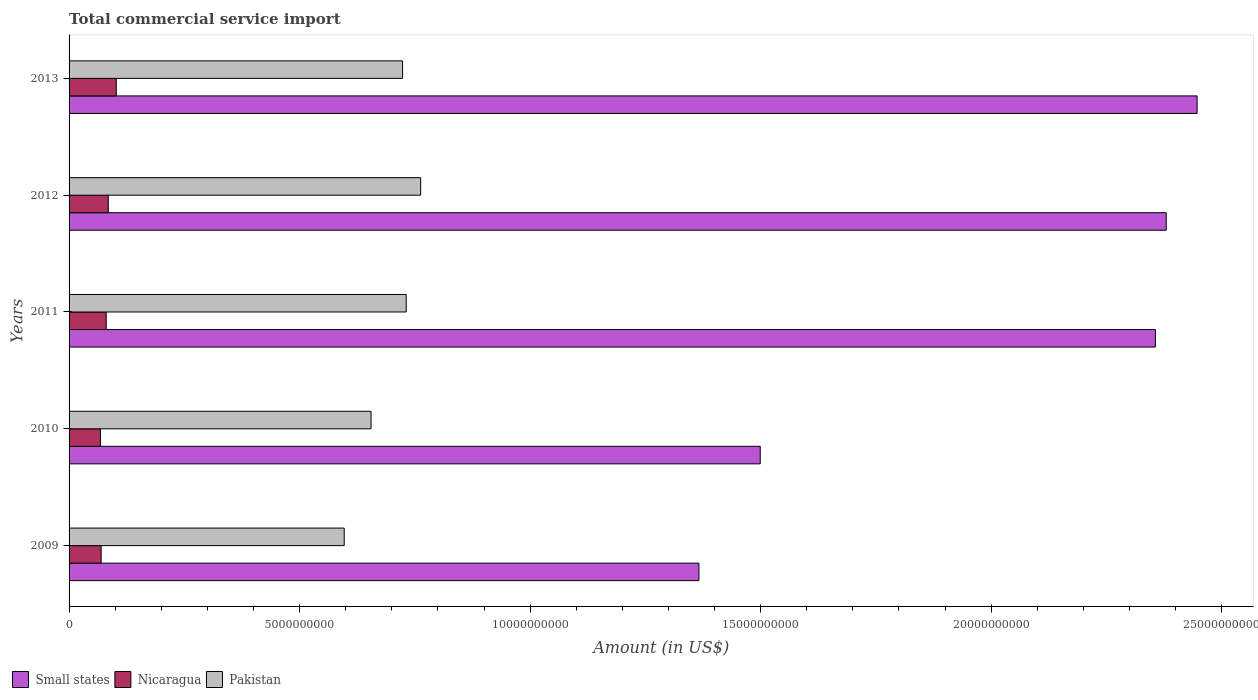How many different coloured bars are there?
Keep it short and to the point. 3. Are the number of bars on each tick of the Y-axis equal?
Keep it short and to the point. Yes. How many bars are there on the 1st tick from the top?
Give a very brief answer. 3. What is the label of the 5th group of bars from the top?
Provide a succinct answer. 2009. What is the total commercial service import in Pakistan in 2011?
Provide a short and direct response. 7.31e+09. Across all years, what is the maximum total commercial service import in Pakistan?
Ensure brevity in your answer.  7.63e+09. Across all years, what is the minimum total commercial service import in Nicaragua?
Keep it short and to the point. 6.80e+08. In which year was the total commercial service import in Small states minimum?
Ensure brevity in your answer.  2009. What is the total total commercial service import in Pakistan in the graph?
Ensure brevity in your answer.  3.47e+1. What is the difference between the total commercial service import in Nicaragua in 2012 and that in 2013?
Keep it short and to the point. -1.73e+08. What is the difference between the total commercial service import in Pakistan in 2010 and the total commercial service import in Nicaragua in 2011?
Provide a succinct answer. 5.74e+09. What is the average total commercial service import in Nicaragua per year?
Offer a very short reply. 8.11e+08. In the year 2010, what is the difference between the total commercial service import in Small states and total commercial service import in Nicaragua?
Ensure brevity in your answer.  1.43e+1. In how many years, is the total commercial service import in Pakistan greater than 24000000000 US$?
Provide a short and direct response. 0. What is the ratio of the total commercial service import in Nicaragua in 2011 to that in 2012?
Your response must be concise. 0.95. Is the difference between the total commercial service import in Small states in 2012 and 2013 greater than the difference between the total commercial service import in Nicaragua in 2012 and 2013?
Keep it short and to the point. No. What is the difference between the highest and the second highest total commercial service import in Pakistan?
Ensure brevity in your answer.  3.13e+08. What is the difference between the highest and the lowest total commercial service import in Small states?
Offer a very short reply. 1.08e+1. In how many years, is the total commercial service import in Small states greater than the average total commercial service import in Small states taken over all years?
Make the answer very short. 3. What does the 2nd bar from the top in 2010 represents?
Offer a very short reply. Nicaragua. What does the 2nd bar from the bottom in 2010 represents?
Give a very brief answer. Nicaragua. How many bars are there?
Provide a short and direct response. 15. Are all the bars in the graph horizontal?
Provide a short and direct response. Yes. Are the values on the major ticks of X-axis written in scientific E-notation?
Provide a succinct answer. No. Does the graph contain grids?
Your answer should be very brief. No. Where does the legend appear in the graph?
Offer a very short reply. Bottom left. How many legend labels are there?
Ensure brevity in your answer.  3. What is the title of the graph?
Make the answer very short. Total commercial service import. Does "Suriname" appear as one of the legend labels in the graph?
Provide a short and direct response. No. What is the label or title of the X-axis?
Your answer should be very brief. Amount (in US$). What is the label or title of the Y-axis?
Offer a terse response. Years. What is the Amount (in US$) in Small states in 2009?
Your response must be concise. 1.37e+1. What is the Amount (in US$) in Nicaragua in 2009?
Ensure brevity in your answer.  6.96e+08. What is the Amount (in US$) of Pakistan in 2009?
Offer a terse response. 5.97e+09. What is the Amount (in US$) of Small states in 2010?
Provide a short and direct response. 1.50e+1. What is the Amount (in US$) of Nicaragua in 2010?
Provide a succinct answer. 6.80e+08. What is the Amount (in US$) of Pakistan in 2010?
Your answer should be compact. 6.55e+09. What is the Amount (in US$) of Small states in 2011?
Ensure brevity in your answer.  2.36e+1. What is the Amount (in US$) in Nicaragua in 2011?
Your response must be concise. 8.05e+08. What is the Amount (in US$) of Pakistan in 2011?
Your answer should be very brief. 7.31e+09. What is the Amount (in US$) of Small states in 2012?
Offer a very short reply. 2.38e+1. What is the Amount (in US$) of Nicaragua in 2012?
Keep it short and to the point. 8.51e+08. What is the Amount (in US$) in Pakistan in 2012?
Make the answer very short. 7.63e+09. What is the Amount (in US$) of Small states in 2013?
Provide a succinct answer. 2.45e+1. What is the Amount (in US$) in Nicaragua in 2013?
Your answer should be compact. 1.02e+09. What is the Amount (in US$) of Pakistan in 2013?
Your answer should be very brief. 7.23e+09. Across all years, what is the maximum Amount (in US$) in Small states?
Keep it short and to the point. 2.45e+1. Across all years, what is the maximum Amount (in US$) of Nicaragua?
Provide a short and direct response. 1.02e+09. Across all years, what is the maximum Amount (in US$) in Pakistan?
Offer a terse response. 7.63e+09. Across all years, what is the minimum Amount (in US$) in Small states?
Provide a succinct answer. 1.37e+1. Across all years, what is the minimum Amount (in US$) of Nicaragua?
Make the answer very short. 6.80e+08. Across all years, what is the minimum Amount (in US$) in Pakistan?
Your answer should be compact. 5.97e+09. What is the total Amount (in US$) in Small states in the graph?
Keep it short and to the point. 1.00e+11. What is the total Amount (in US$) of Nicaragua in the graph?
Your response must be concise. 4.06e+09. What is the total Amount (in US$) in Pakistan in the graph?
Your answer should be very brief. 3.47e+1. What is the difference between the Amount (in US$) in Small states in 2009 and that in 2010?
Your answer should be very brief. -1.33e+09. What is the difference between the Amount (in US$) of Nicaragua in 2009 and that in 2010?
Ensure brevity in your answer.  1.56e+07. What is the difference between the Amount (in US$) of Pakistan in 2009 and that in 2010?
Give a very brief answer. -5.83e+08. What is the difference between the Amount (in US$) in Small states in 2009 and that in 2011?
Provide a short and direct response. -9.90e+09. What is the difference between the Amount (in US$) of Nicaragua in 2009 and that in 2011?
Offer a terse response. -1.10e+08. What is the difference between the Amount (in US$) of Pakistan in 2009 and that in 2011?
Provide a succinct answer. -1.35e+09. What is the difference between the Amount (in US$) of Small states in 2009 and that in 2012?
Offer a very short reply. -1.01e+1. What is the difference between the Amount (in US$) in Nicaragua in 2009 and that in 2012?
Keep it short and to the point. -1.55e+08. What is the difference between the Amount (in US$) of Pakistan in 2009 and that in 2012?
Make the answer very short. -1.66e+09. What is the difference between the Amount (in US$) in Small states in 2009 and that in 2013?
Offer a terse response. -1.08e+1. What is the difference between the Amount (in US$) in Nicaragua in 2009 and that in 2013?
Provide a succinct answer. -3.28e+08. What is the difference between the Amount (in US$) of Pakistan in 2009 and that in 2013?
Provide a short and direct response. -1.27e+09. What is the difference between the Amount (in US$) of Small states in 2010 and that in 2011?
Ensure brevity in your answer.  -8.57e+09. What is the difference between the Amount (in US$) of Nicaragua in 2010 and that in 2011?
Ensure brevity in your answer.  -1.25e+08. What is the difference between the Amount (in US$) of Pakistan in 2010 and that in 2011?
Provide a succinct answer. -7.63e+08. What is the difference between the Amount (in US$) in Small states in 2010 and that in 2012?
Offer a very short reply. -8.81e+09. What is the difference between the Amount (in US$) in Nicaragua in 2010 and that in 2012?
Your answer should be compact. -1.71e+08. What is the difference between the Amount (in US$) of Pakistan in 2010 and that in 2012?
Your answer should be compact. -1.08e+09. What is the difference between the Amount (in US$) of Small states in 2010 and that in 2013?
Your answer should be compact. -9.48e+09. What is the difference between the Amount (in US$) of Nicaragua in 2010 and that in 2013?
Ensure brevity in your answer.  -3.44e+08. What is the difference between the Amount (in US$) in Pakistan in 2010 and that in 2013?
Your response must be concise. -6.84e+08. What is the difference between the Amount (in US$) of Small states in 2011 and that in 2012?
Provide a short and direct response. -2.34e+08. What is the difference between the Amount (in US$) in Nicaragua in 2011 and that in 2012?
Offer a terse response. -4.55e+07. What is the difference between the Amount (in US$) of Pakistan in 2011 and that in 2012?
Ensure brevity in your answer.  -3.13e+08. What is the difference between the Amount (in US$) in Small states in 2011 and that in 2013?
Give a very brief answer. -9.04e+08. What is the difference between the Amount (in US$) in Nicaragua in 2011 and that in 2013?
Your answer should be very brief. -2.19e+08. What is the difference between the Amount (in US$) of Pakistan in 2011 and that in 2013?
Provide a short and direct response. 7.90e+07. What is the difference between the Amount (in US$) of Small states in 2012 and that in 2013?
Provide a short and direct response. -6.70e+08. What is the difference between the Amount (in US$) in Nicaragua in 2012 and that in 2013?
Your response must be concise. -1.73e+08. What is the difference between the Amount (in US$) in Pakistan in 2012 and that in 2013?
Offer a terse response. 3.92e+08. What is the difference between the Amount (in US$) of Small states in 2009 and the Amount (in US$) of Nicaragua in 2010?
Make the answer very short. 1.30e+1. What is the difference between the Amount (in US$) in Small states in 2009 and the Amount (in US$) in Pakistan in 2010?
Make the answer very short. 7.11e+09. What is the difference between the Amount (in US$) in Nicaragua in 2009 and the Amount (in US$) in Pakistan in 2010?
Your response must be concise. -5.85e+09. What is the difference between the Amount (in US$) of Small states in 2009 and the Amount (in US$) of Nicaragua in 2011?
Provide a short and direct response. 1.29e+1. What is the difference between the Amount (in US$) of Small states in 2009 and the Amount (in US$) of Pakistan in 2011?
Give a very brief answer. 6.35e+09. What is the difference between the Amount (in US$) of Nicaragua in 2009 and the Amount (in US$) of Pakistan in 2011?
Your answer should be very brief. -6.62e+09. What is the difference between the Amount (in US$) of Small states in 2009 and the Amount (in US$) of Nicaragua in 2012?
Give a very brief answer. 1.28e+1. What is the difference between the Amount (in US$) of Small states in 2009 and the Amount (in US$) of Pakistan in 2012?
Your response must be concise. 6.04e+09. What is the difference between the Amount (in US$) of Nicaragua in 2009 and the Amount (in US$) of Pakistan in 2012?
Ensure brevity in your answer.  -6.93e+09. What is the difference between the Amount (in US$) in Small states in 2009 and the Amount (in US$) in Nicaragua in 2013?
Provide a short and direct response. 1.26e+1. What is the difference between the Amount (in US$) of Small states in 2009 and the Amount (in US$) of Pakistan in 2013?
Make the answer very short. 6.43e+09. What is the difference between the Amount (in US$) in Nicaragua in 2009 and the Amount (in US$) in Pakistan in 2013?
Give a very brief answer. -6.54e+09. What is the difference between the Amount (in US$) in Small states in 2010 and the Amount (in US$) in Nicaragua in 2011?
Your answer should be very brief. 1.42e+1. What is the difference between the Amount (in US$) of Small states in 2010 and the Amount (in US$) of Pakistan in 2011?
Offer a terse response. 7.68e+09. What is the difference between the Amount (in US$) of Nicaragua in 2010 and the Amount (in US$) of Pakistan in 2011?
Offer a very short reply. -6.63e+09. What is the difference between the Amount (in US$) in Small states in 2010 and the Amount (in US$) in Nicaragua in 2012?
Provide a short and direct response. 1.41e+1. What is the difference between the Amount (in US$) in Small states in 2010 and the Amount (in US$) in Pakistan in 2012?
Provide a short and direct response. 7.36e+09. What is the difference between the Amount (in US$) in Nicaragua in 2010 and the Amount (in US$) in Pakistan in 2012?
Your answer should be very brief. -6.95e+09. What is the difference between the Amount (in US$) in Small states in 2010 and the Amount (in US$) in Nicaragua in 2013?
Your response must be concise. 1.40e+1. What is the difference between the Amount (in US$) of Small states in 2010 and the Amount (in US$) of Pakistan in 2013?
Keep it short and to the point. 7.76e+09. What is the difference between the Amount (in US$) of Nicaragua in 2010 and the Amount (in US$) of Pakistan in 2013?
Ensure brevity in your answer.  -6.55e+09. What is the difference between the Amount (in US$) in Small states in 2011 and the Amount (in US$) in Nicaragua in 2012?
Offer a terse response. 2.27e+1. What is the difference between the Amount (in US$) of Small states in 2011 and the Amount (in US$) of Pakistan in 2012?
Your answer should be very brief. 1.59e+1. What is the difference between the Amount (in US$) in Nicaragua in 2011 and the Amount (in US$) in Pakistan in 2012?
Provide a succinct answer. -6.82e+09. What is the difference between the Amount (in US$) in Small states in 2011 and the Amount (in US$) in Nicaragua in 2013?
Provide a short and direct response. 2.25e+1. What is the difference between the Amount (in US$) in Small states in 2011 and the Amount (in US$) in Pakistan in 2013?
Offer a very short reply. 1.63e+1. What is the difference between the Amount (in US$) of Nicaragua in 2011 and the Amount (in US$) of Pakistan in 2013?
Offer a terse response. -6.43e+09. What is the difference between the Amount (in US$) of Small states in 2012 and the Amount (in US$) of Nicaragua in 2013?
Keep it short and to the point. 2.28e+1. What is the difference between the Amount (in US$) of Small states in 2012 and the Amount (in US$) of Pakistan in 2013?
Your response must be concise. 1.66e+1. What is the difference between the Amount (in US$) in Nicaragua in 2012 and the Amount (in US$) in Pakistan in 2013?
Ensure brevity in your answer.  -6.38e+09. What is the average Amount (in US$) of Small states per year?
Provide a short and direct response. 2.01e+1. What is the average Amount (in US$) of Nicaragua per year?
Your response must be concise. 8.11e+08. What is the average Amount (in US$) in Pakistan per year?
Offer a terse response. 6.94e+09. In the year 2009, what is the difference between the Amount (in US$) of Small states and Amount (in US$) of Nicaragua?
Keep it short and to the point. 1.30e+1. In the year 2009, what is the difference between the Amount (in US$) in Small states and Amount (in US$) in Pakistan?
Your answer should be compact. 7.69e+09. In the year 2009, what is the difference between the Amount (in US$) of Nicaragua and Amount (in US$) of Pakistan?
Your answer should be very brief. -5.27e+09. In the year 2010, what is the difference between the Amount (in US$) of Small states and Amount (in US$) of Nicaragua?
Your response must be concise. 1.43e+1. In the year 2010, what is the difference between the Amount (in US$) of Small states and Amount (in US$) of Pakistan?
Give a very brief answer. 8.44e+09. In the year 2010, what is the difference between the Amount (in US$) of Nicaragua and Amount (in US$) of Pakistan?
Offer a terse response. -5.87e+09. In the year 2011, what is the difference between the Amount (in US$) in Small states and Amount (in US$) in Nicaragua?
Provide a succinct answer. 2.28e+1. In the year 2011, what is the difference between the Amount (in US$) in Small states and Amount (in US$) in Pakistan?
Provide a succinct answer. 1.62e+1. In the year 2011, what is the difference between the Amount (in US$) in Nicaragua and Amount (in US$) in Pakistan?
Make the answer very short. -6.51e+09. In the year 2012, what is the difference between the Amount (in US$) in Small states and Amount (in US$) in Nicaragua?
Offer a terse response. 2.29e+1. In the year 2012, what is the difference between the Amount (in US$) of Small states and Amount (in US$) of Pakistan?
Your answer should be compact. 1.62e+1. In the year 2012, what is the difference between the Amount (in US$) in Nicaragua and Amount (in US$) in Pakistan?
Keep it short and to the point. -6.78e+09. In the year 2013, what is the difference between the Amount (in US$) in Small states and Amount (in US$) in Nicaragua?
Give a very brief answer. 2.34e+1. In the year 2013, what is the difference between the Amount (in US$) in Small states and Amount (in US$) in Pakistan?
Provide a short and direct response. 1.72e+1. In the year 2013, what is the difference between the Amount (in US$) of Nicaragua and Amount (in US$) of Pakistan?
Offer a very short reply. -6.21e+09. What is the ratio of the Amount (in US$) of Small states in 2009 to that in 2010?
Your answer should be very brief. 0.91. What is the ratio of the Amount (in US$) in Nicaragua in 2009 to that in 2010?
Offer a very short reply. 1.02. What is the ratio of the Amount (in US$) in Pakistan in 2009 to that in 2010?
Keep it short and to the point. 0.91. What is the ratio of the Amount (in US$) of Small states in 2009 to that in 2011?
Provide a short and direct response. 0.58. What is the ratio of the Amount (in US$) of Nicaragua in 2009 to that in 2011?
Keep it short and to the point. 0.86. What is the ratio of the Amount (in US$) in Pakistan in 2009 to that in 2011?
Offer a terse response. 0.82. What is the ratio of the Amount (in US$) of Small states in 2009 to that in 2012?
Make the answer very short. 0.57. What is the ratio of the Amount (in US$) of Nicaragua in 2009 to that in 2012?
Your response must be concise. 0.82. What is the ratio of the Amount (in US$) of Pakistan in 2009 to that in 2012?
Your answer should be compact. 0.78. What is the ratio of the Amount (in US$) of Small states in 2009 to that in 2013?
Ensure brevity in your answer.  0.56. What is the ratio of the Amount (in US$) in Nicaragua in 2009 to that in 2013?
Offer a very short reply. 0.68. What is the ratio of the Amount (in US$) in Pakistan in 2009 to that in 2013?
Make the answer very short. 0.82. What is the ratio of the Amount (in US$) in Small states in 2010 to that in 2011?
Provide a short and direct response. 0.64. What is the ratio of the Amount (in US$) of Nicaragua in 2010 to that in 2011?
Your answer should be very brief. 0.84. What is the ratio of the Amount (in US$) of Pakistan in 2010 to that in 2011?
Ensure brevity in your answer.  0.9. What is the ratio of the Amount (in US$) of Small states in 2010 to that in 2012?
Make the answer very short. 0.63. What is the ratio of the Amount (in US$) of Nicaragua in 2010 to that in 2012?
Offer a very short reply. 0.8. What is the ratio of the Amount (in US$) of Pakistan in 2010 to that in 2012?
Keep it short and to the point. 0.86. What is the ratio of the Amount (in US$) in Small states in 2010 to that in 2013?
Provide a short and direct response. 0.61. What is the ratio of the Amount (in US$) in Nicaragua in 2010 to that in 2013?
Make the answer very short. 0.66. What is the ratio of the Amount (in US$) of Pakistan in 2010 to that in 2013?
Offer a very short reply. 0.91. What is the ratio of the Amount (in US$) of Small states in 2011 to that in 2012?
Ensure brevity in your answer.  0.99. What is the ratio of the Amount (in US$) in Nicaragua in 2011 to that in 2012?
Make the answer very short. 0.95. What is the ratio of the Amount (in US$) of Pakistan in 2011 to that in 2012?
Provide a succinct answer. 0.96. What is the ratio of the Amount (in US$) of Small states in 2011 to that in 2013?
Your answer should be very brief. 0.96. What is the ratio of the Amount (in US$) of Nicaragua in 2011 to that in 2013?
Your response must be concise. 0.79. What is the ratio of the Amount (in US$) in Pakistan in 2011 to that in 2013?
Offer a very short reply. 1.01. What is the ratio of the Amount (in US$) of Small states in 2012 to that in 2013?
Offer a terse response. 0.97. What is the ratio of the Amount (in US$) in Nicaragua in 2012 to that in 2013?
Your answer should be very brief. 0.83. What is the ratio of the Amount (in US$) in Pakistan in 2012 to that in 2013?
Give a very brief answer. 1.05. What is the difference between the highest and the second highest Amount (in US$) of Small states?
Your response must be concise. 6.70e+08. What is the difference between the highest and the second highest Amount (in US$) of Nicaragua?
Your answer should be very brief. 1.73e+08. What is the difference between the highest and the second highest Amount (in US$) of Pakistan?
Your response must be concise. 3.13e+08. What is the difference between the highest and the lowest Amount (in US$) of Small states?
Give a very brief answer. 1.08e+1. What is the difference between the highest and the lowest Amount (in US$) of Nicaragua?
Offer a very short reply. 3.44e+08. What is the difference between the highest and the lowest Amount (in US$) in Pakistan?
Make the answer very short. 1.66e+09. 